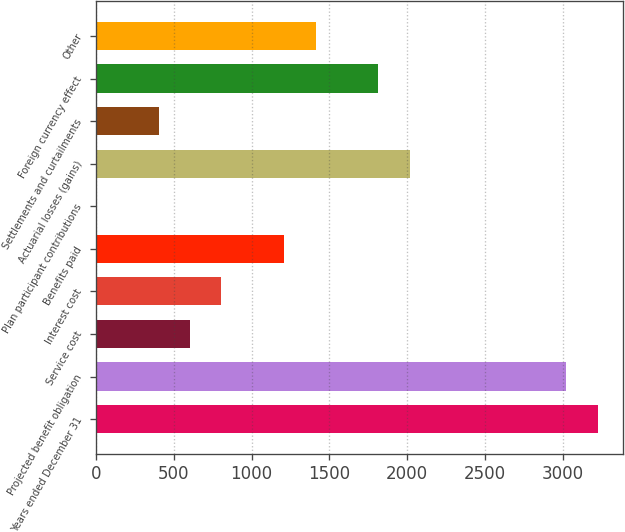<chart> <loc_0><loc_0><loc_500><loc_500><bar_chart><fcel>Years ended December 31<fcel>Projected benefit obligation<fcel>Service cost<fcel>Interest cost<fcel>Benefits paid<fcel>Plan participant contributions<fcel>Actuarial losses (gains)<fcel>Settlements and curtailments<fcel>Foreign currency effect<fcel>Other<nl><fcel>3225.48<fcel>3023.9<fcel>604.94<fcel>806.52<fcel>1209.68<fcel>0.2<fcel>2016<fcel>403.36<fcel>1814.42<fcel>1411.26<nl></chart> 